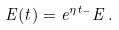<formula> <loc_0><loc_0><loc_500><loc_500>E ( t ) = e ^ { \eta t _ { - } } E \, .</formula> 